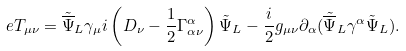<formula> <loc_0><loc_0><loc_500><loc_500>e T _ { \mu \nu } = { \tilde { \overline { \Psi } } _ { L } } { \gamma _ { \mu } } i \left ( D _ { \nu } - \frac { 1 } { 2 } \Gamma _ { \alpha \nu } ^ { \alpha } \right ) { \tilde { \Psi } } _ { L } - \frac { i } { 2 } g _ { \mu \nu } \partial _ { \alpha } ( { \tilde { \overline { \Psi } } } _ { L } \gamma ^ { \alpha } { \tilde { \Psi } _ { L } } ) . \,</formula> 